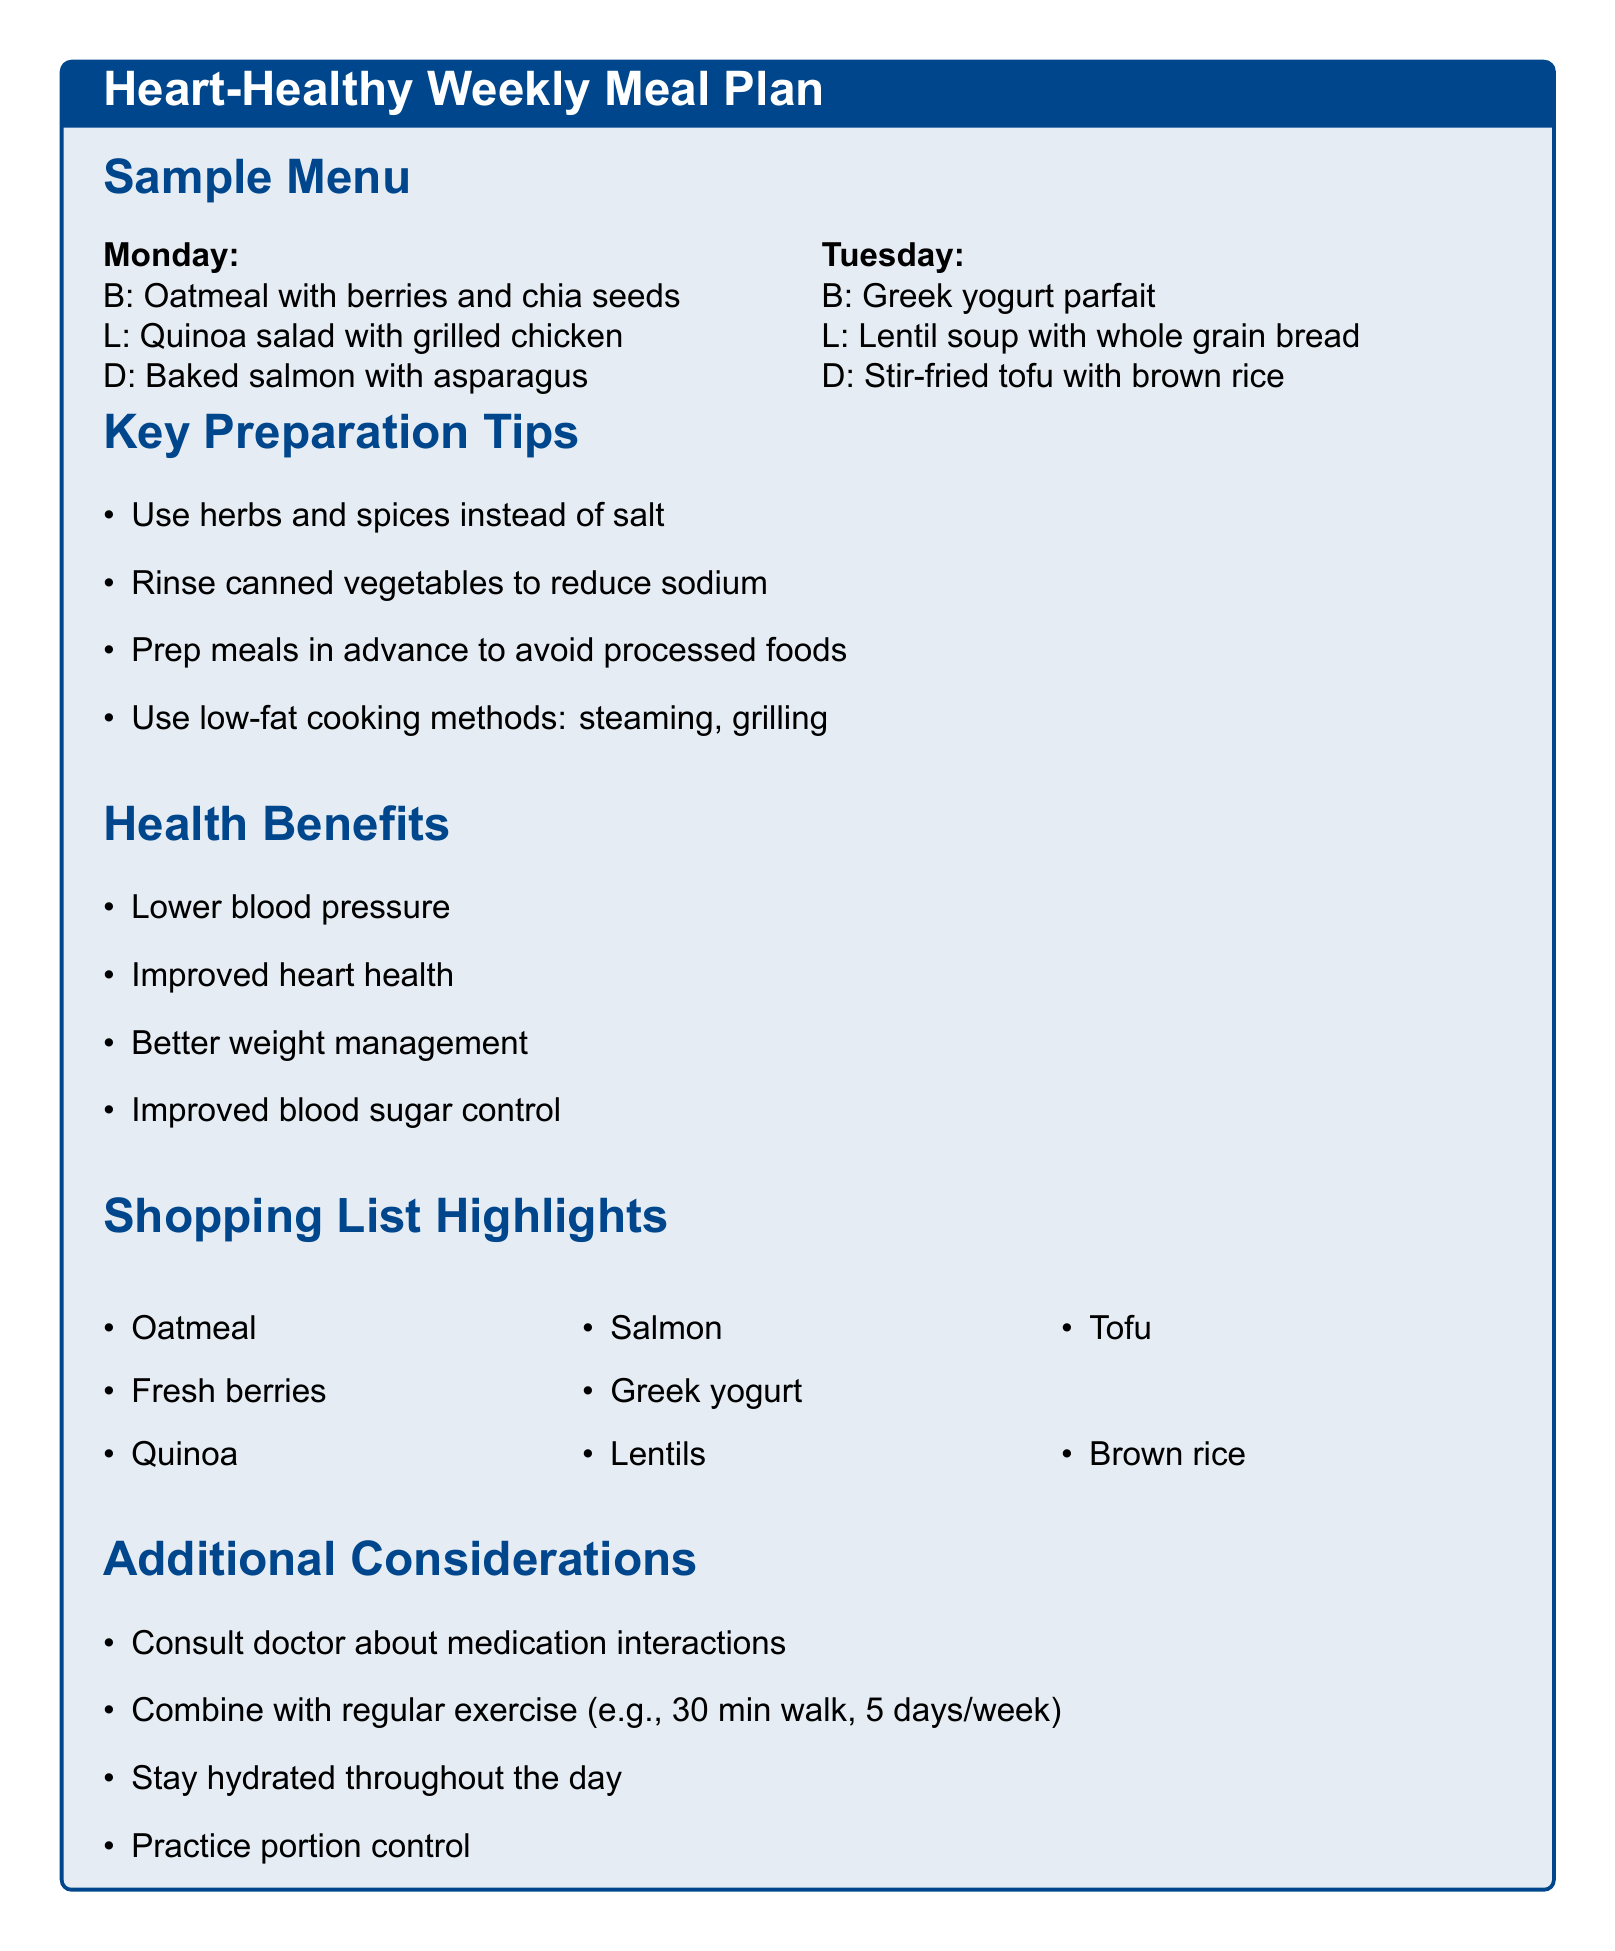What is the breakfast for Tuesday? The breakfast listed for Tuesday is Greek yogurt parfait.
Answer: Greek yogurt parfait How many days are included in the meal plan? The meal plan covers five days, from Monday to Friday.
Answer: Five days What is a recommended cooking method to lower added fats? The document suggests several cooking methods, including steaming.
Answer: Steaming What ingredient is suggested to reduce sodium in canned goods? Rinsing canned vegetables and beans is recommended to reduce sodium content.
Answer: Rinsing What is one benefit of reducing sodium intake mentioned in the document? One benefit is lowering blood pressure, which eases strain on blood vessels.
Answer: Lower blood pressure How many items are listed in the shopping list? A total of thirty items are included in the shopping list.
Answer: Thirty items What is advised for meal preparation to avoid processed foods? The document suggests preparing meals in advance.
Answer: Preparing meals in advance What should be monitored according to the additional considerations? The document advises monitoring medication interactions.
Answer: Medication interactions 